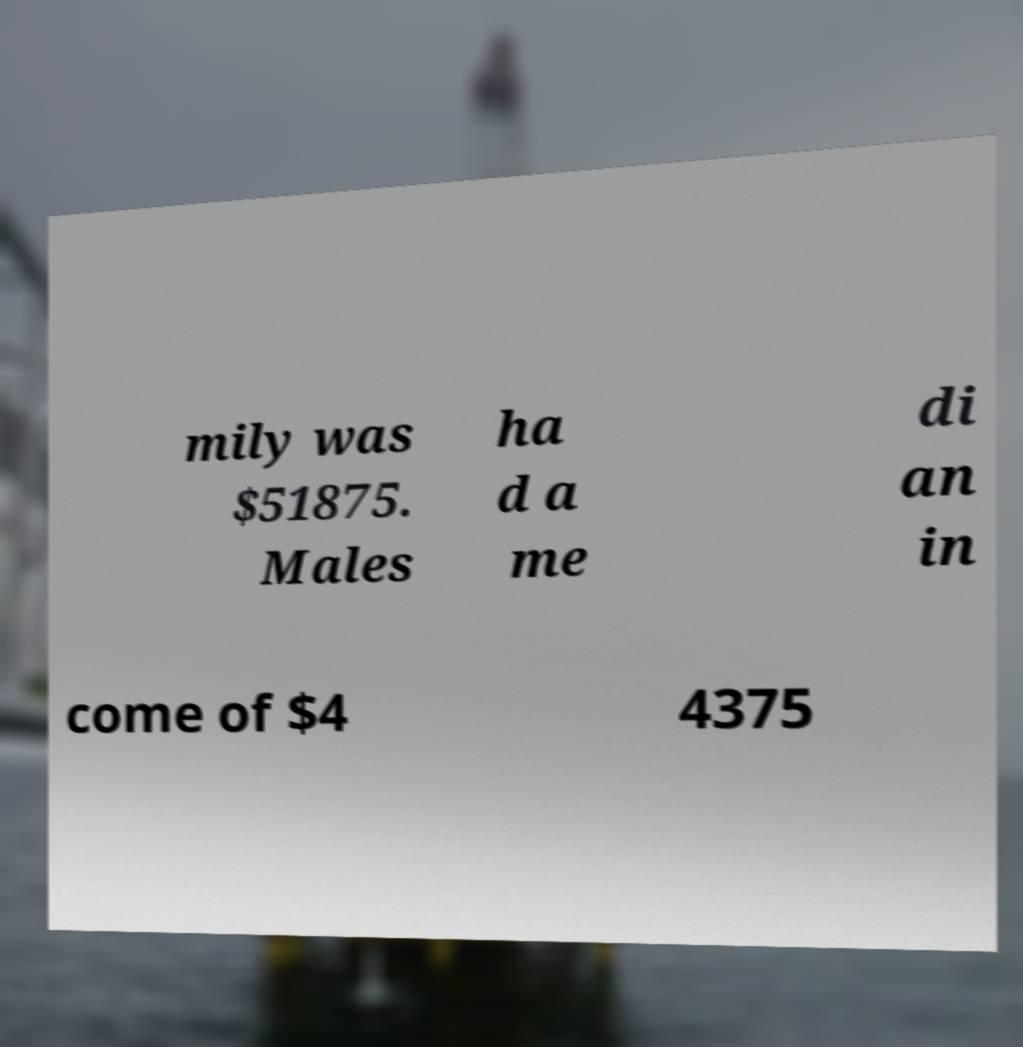Please identify and transcribe the text found in this image. mily was $51875. Males ha d a me di an in come of $4 4375 